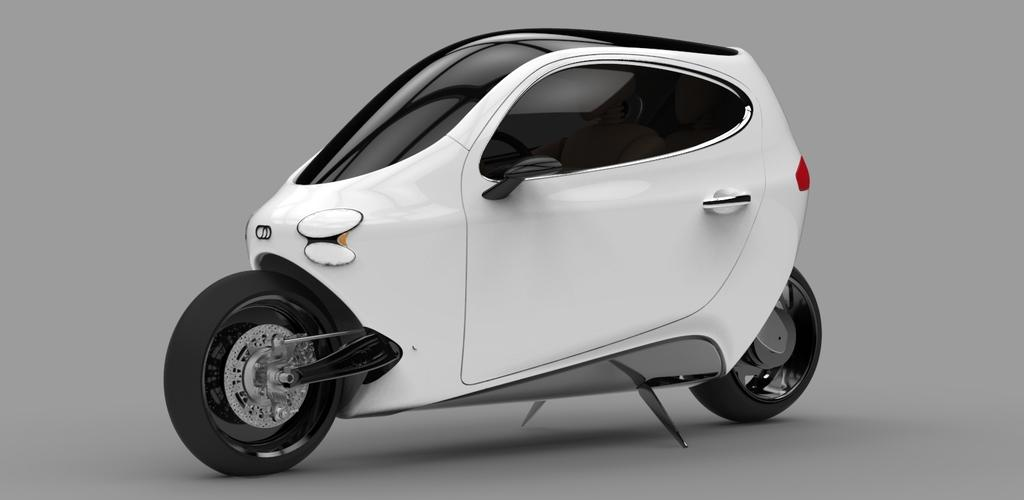What is the main subject of the image? There is a vehicle in the image. Are there any other vehicles present in the image? Yes, there are two other vehicles parked on the ground in the image. What type of potato is being used to drive the vehicle in the image? There is no potato present in the image, and the vehicle is not being driven by a potato. 